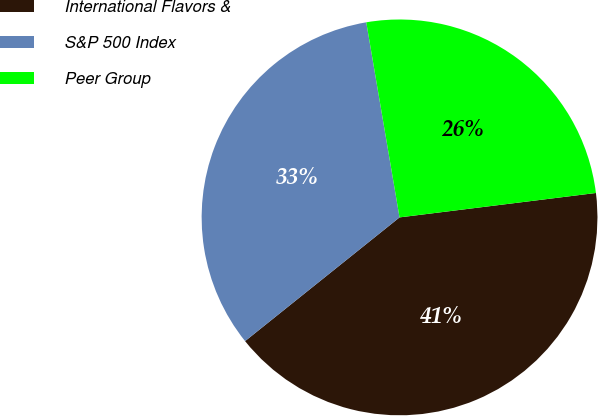<chart> <loc_0><loc_0><loc_500><loc_500><pie_chart><fcel>International Flavors &<fcel>S&P 500 Index<fcel>Peer Group<nl><fcel>41.22%<fcel>33.06%<fcel>25.72%<nl></chart> 